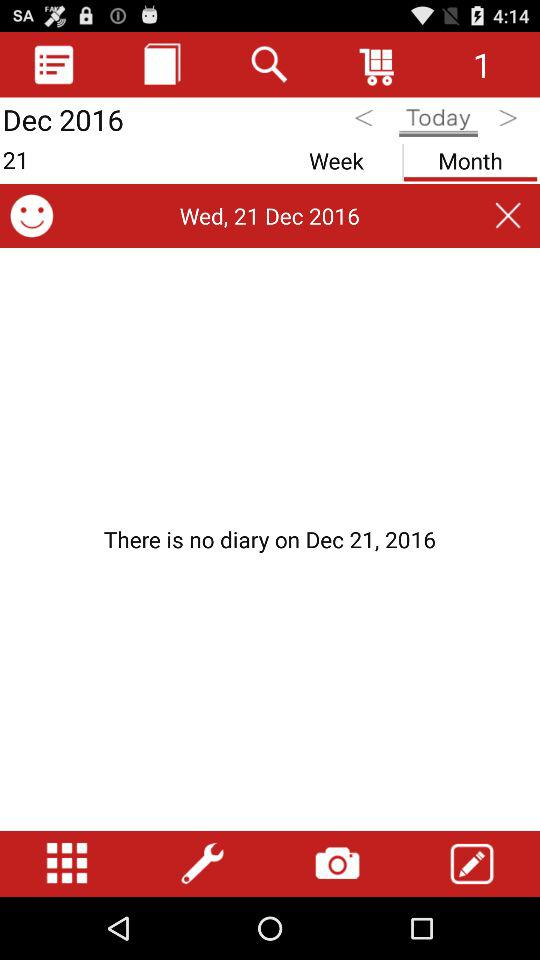What date is displayed on the screen? The displayed date is Wednesday, December 21, 2016. 